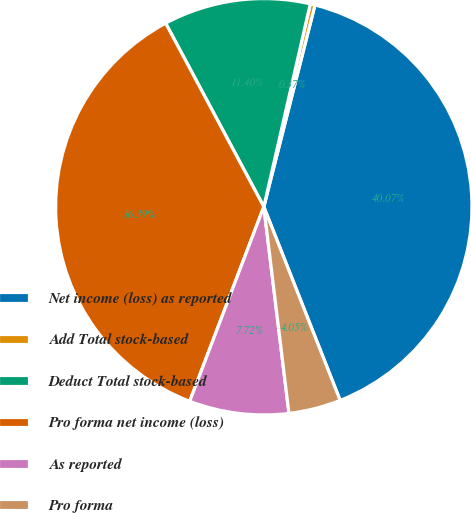<chart> <loc_0><loc_0><loc_500><loc_500><pie_chart><fcel>Net income (loss) as reported<fcel>Add Total stock-based<fcel>Deduct Total stock-based<fcel>Pro forma net income (loss)<fcel>As reported<fcel>Pro forma<nl><fcel>40.07%<fcel>0.37%<fcel>11.4%<fcel>36.39%<fcel>7.72%<fcel>4.05%<nl></chart> 